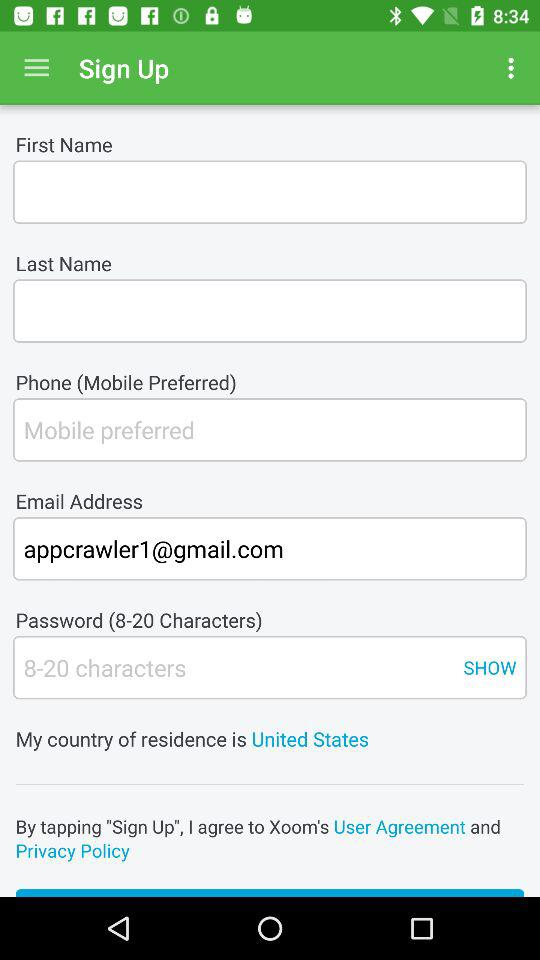What is the email address? The email address is appcrawler1@gmail.com. 